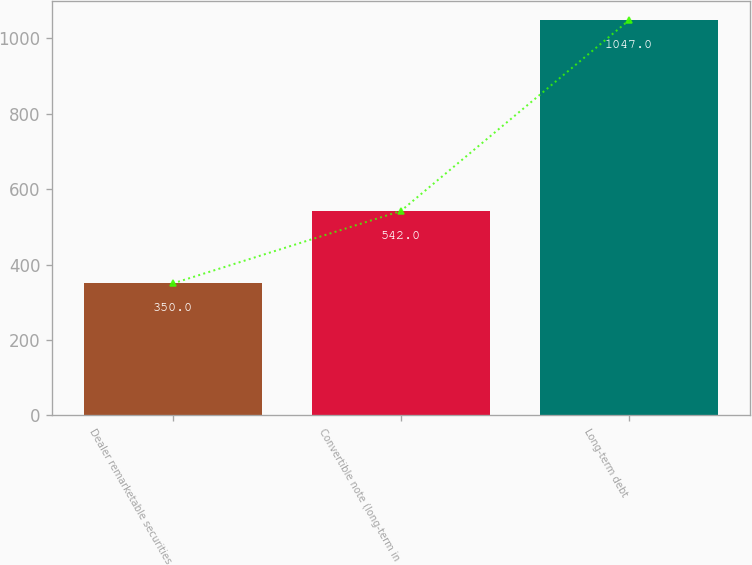<chart> <loc_0><loc_0><loc_500><loc_500><bar_chart><fcel>Dealer remarketable securities<fcel>Convertible note (long-term in<fcel>Long-term debt<nl><fcel>350<fcel>542<fcel>1047<nl></chart> 